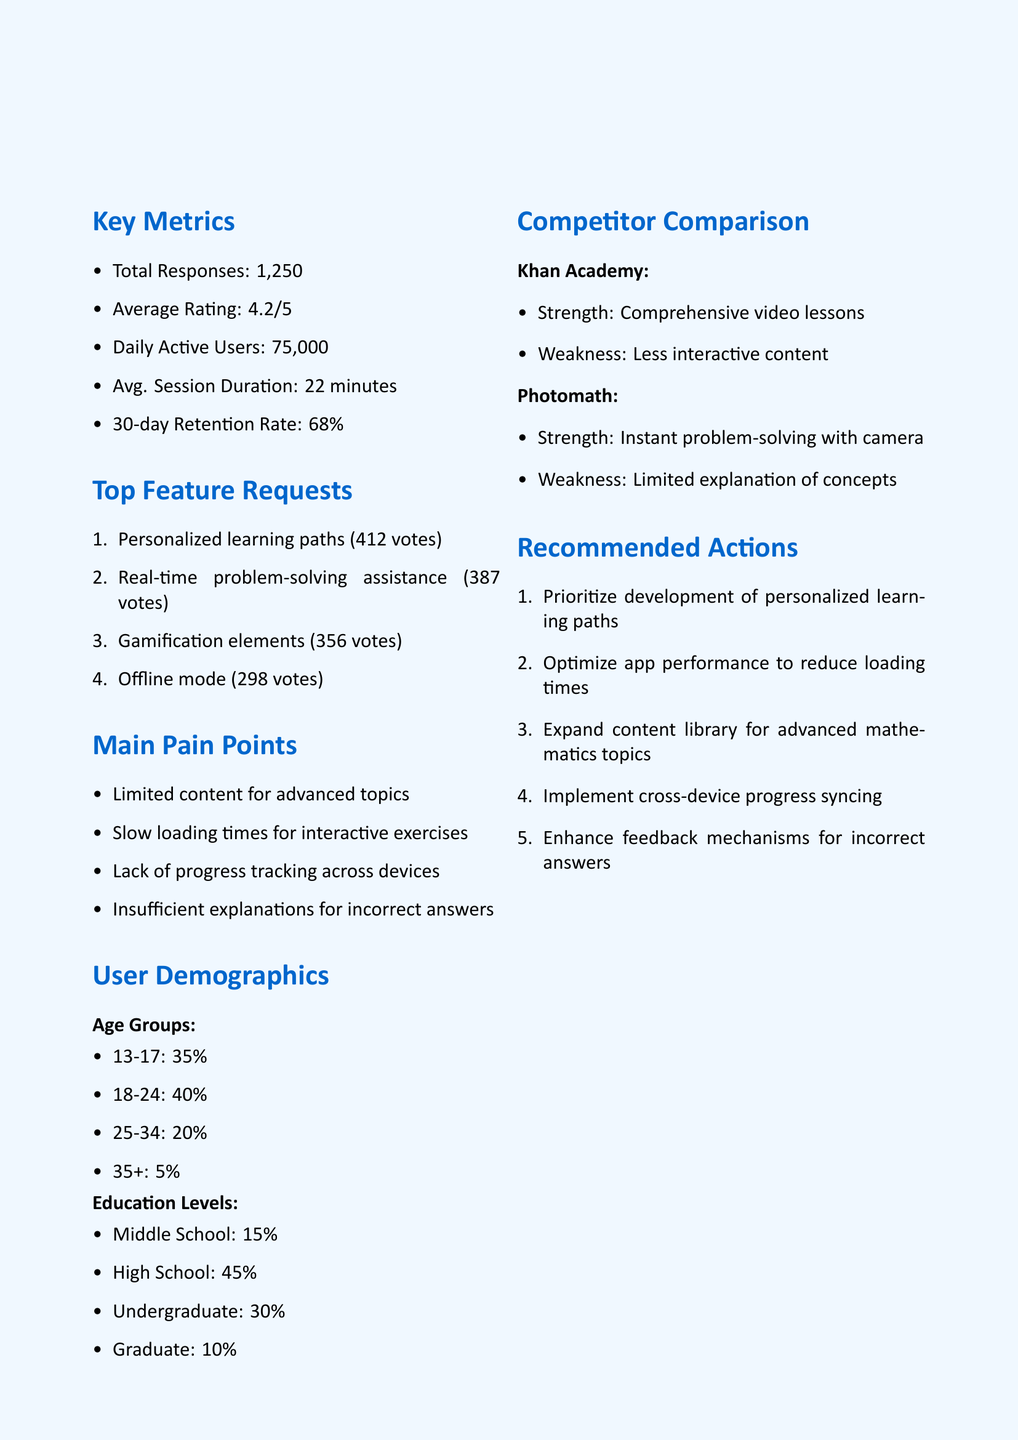What is the average rating of the app? The average rating is mentioned in the key metrics section of the document.
Answer: 4.2 How many total responses were received? The total responses are listed in the user feedback summary.
Answer: 1250 What is the second most requested feature? The ranking of feature requests indicates the second position in the list of top feature requests.
Answer: Real-time problem-solving assistance What percentage of users are aged 18-24? The user demographics section provides the breakdown of age groups with their corresponding percentages.
Answer: 40% What are the main pain points identified? The document lists the key issues under the main pain points section.
Answer: Limited content for advanced topics, Slow loading times for interactive exercises, Lack of progress tracking across devices, Insufficient explanations for incorrect answers Which competitor has a weakness in less interactive content? The competitor comparison section outlines the strengths and weaknesses of competitors.
Answer: Khan Academy What recommended action addresses loading times? The section on recommended actions specifically mentions optimizing app performance.
Answer: Optimize app performance to reduce loading times What is the percentage of high school users? The user demographics section lists the education levels and their respective percentages.
Answer: 45% Who prepared the document? The document specifies the team responsible for its preparation at the bottom.
Answer: Product Management Team 